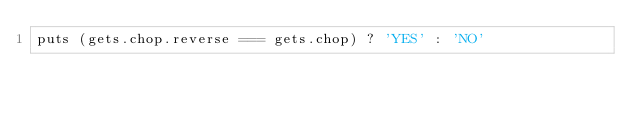Convert code to text. <code><loc_0><loc_0><loc_500><loc_500><_Ruby_>puts (gets.chop.reverse === gets.chop) ? 'YES' : 'NO'</code> 